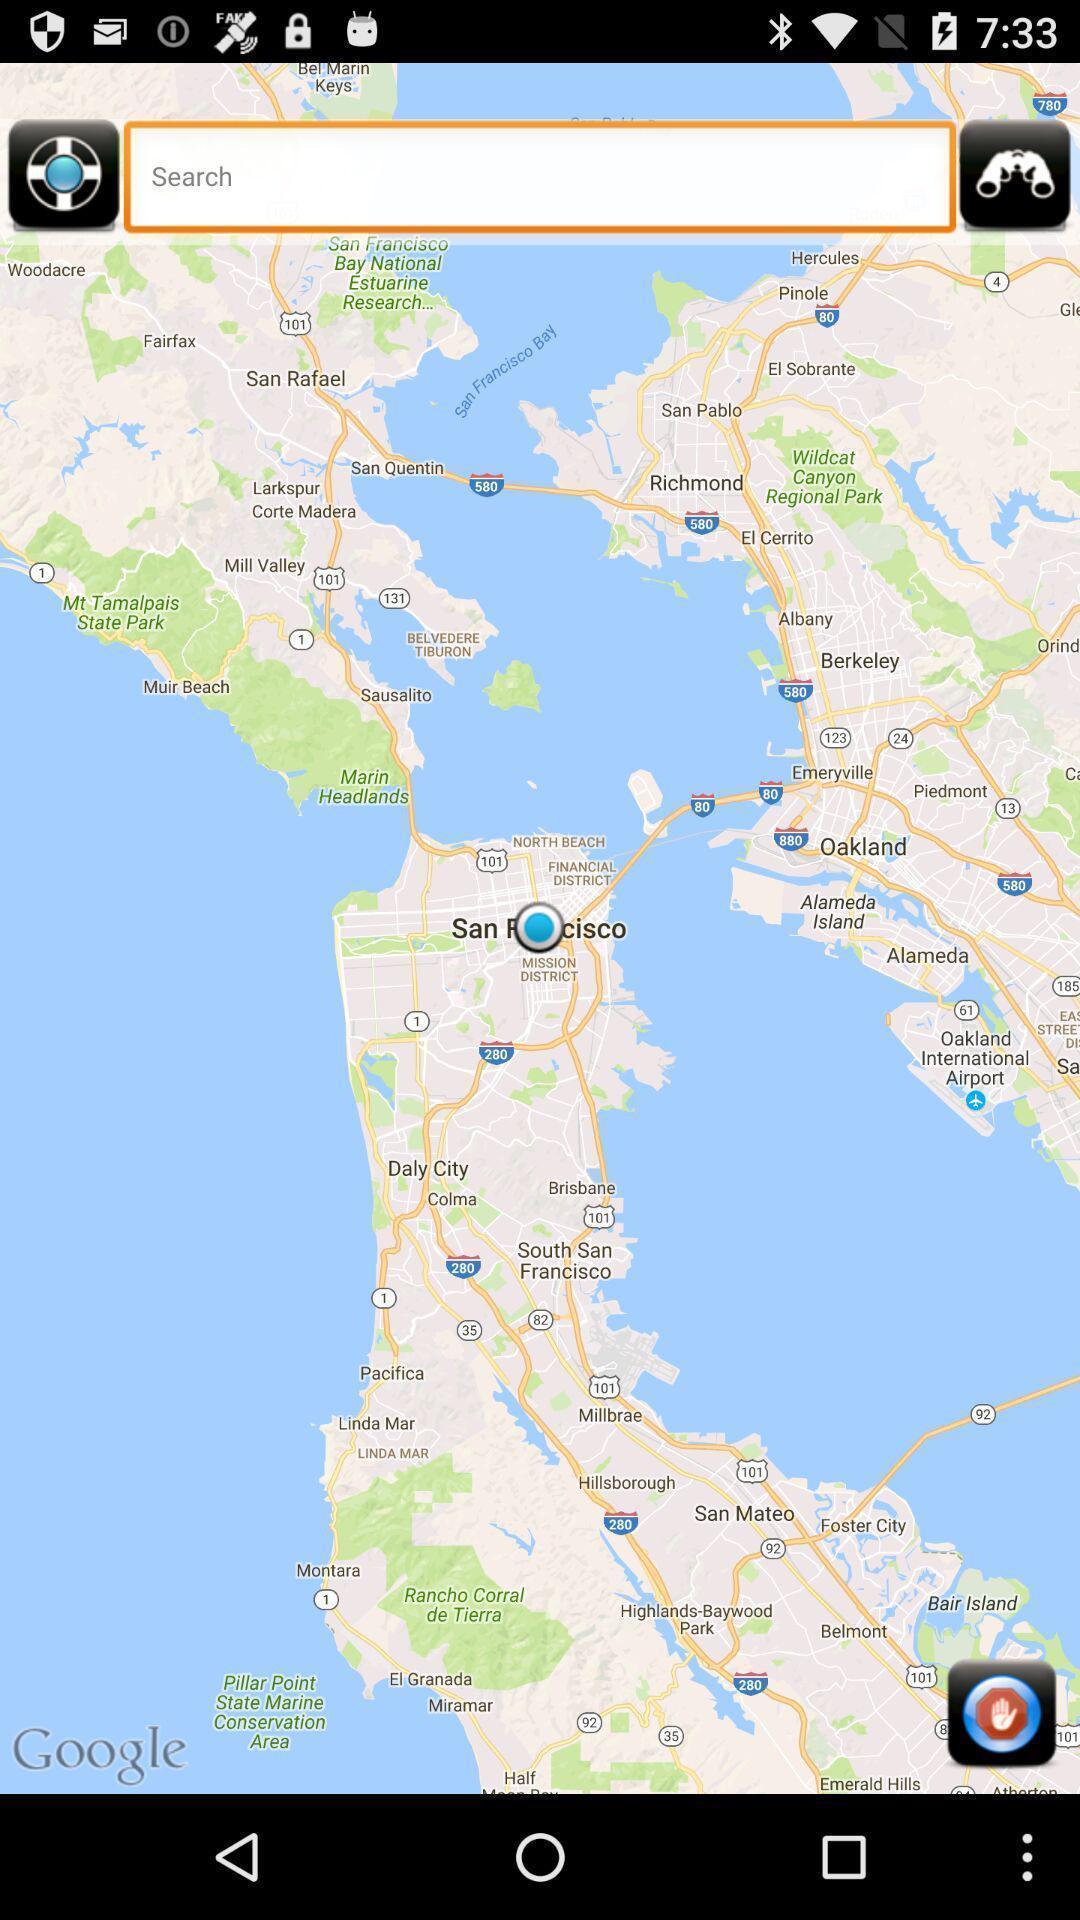Describe this image in words. Search page for searching location of cops. 